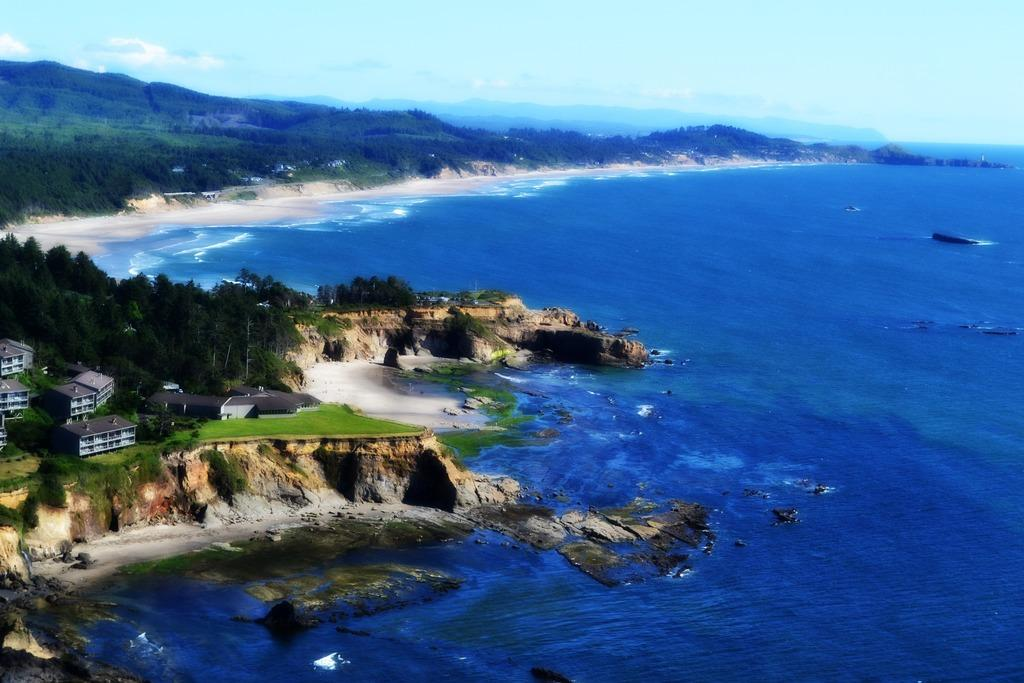What type of structures can be seen in the image? There are buildings in the image. What natural element is visible in the image? There is water visible in the image. What type of vegetation is present in the image? There are trees in the image. What type of landscape feature can be seen in the background of the image? There are hills visible in the background of the image. Where is the plate located in the image? There is no plate present in the image. What type of joke can be heard being told in the image? There is no joke being told in the image, as it is a visual medium. 